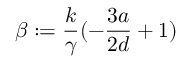<formula> <loc_0><loc_0><loc_500><loc_500>\beta \colon = \frac { k } { \gamma } ( - \frac { 3 a } { 2 d } + 1 )</formula> 